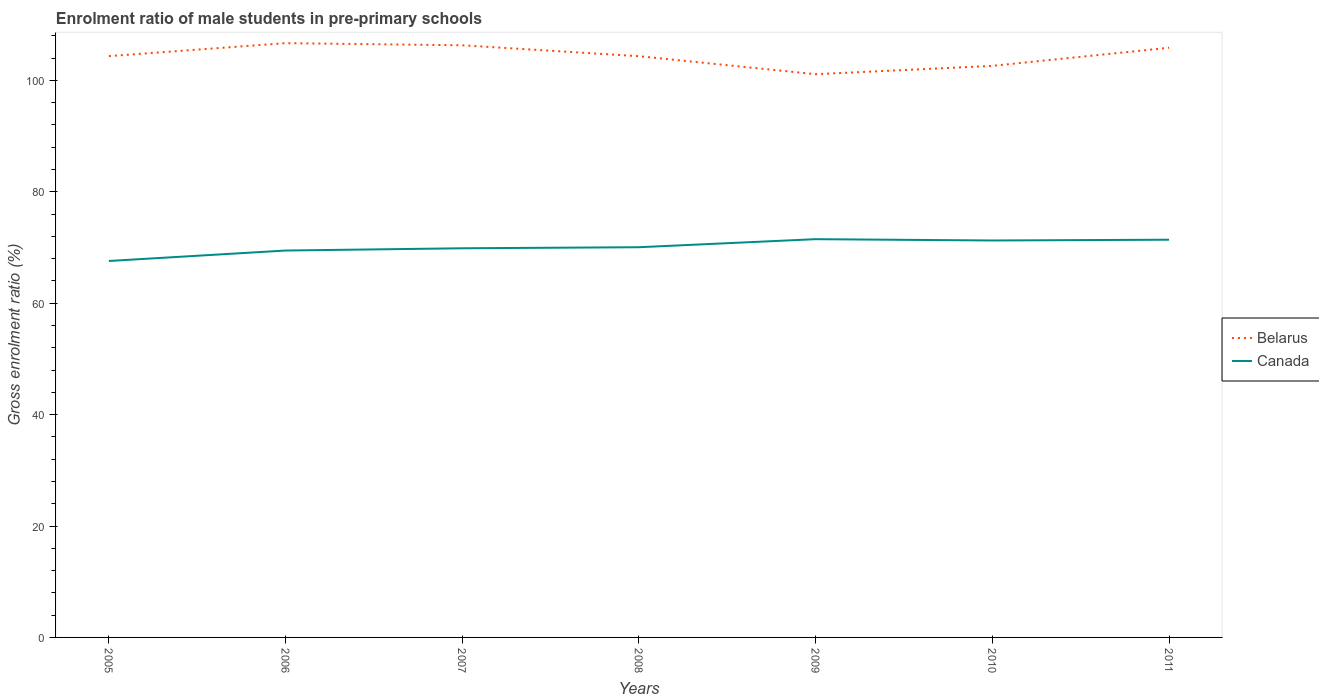How many different coloured lines are there?
Provide a short and direct response. 2. Is the number of lines equal to the number of legend labels?
Make the answer very short. Yes. Across all years, what is the maximum enrolment ratio of male students in pre-primary schools in Canada?
Keep it short and to the point. 67.57. In which year was the enrolment ratio of male students in pre-primary schools in Canada maximum?
Provide a short and direct response. 2005. What is the total enrolment ratio of male students in pre-primary schools in Canada in the graph?
Provide a short and direct response. -1.64. What is the difference between the highest and the second highest enrolment ratio of male students in pre-primary schools in Belarus?
Ensure brevity in your answer.  5.57. What is the difference between the highest and the lowest enrolment ratio of male students in pre-primary schools in Belarus?
Offer a terse response. 3. Is the enrolment ratio of male students in pre-primary schools in Belarus strictly greater than the enrolment ratio of male students in pre-primary schools in Canada over the years?
Your answer should be very brief. No. How many lines are there?
Keep it short and to the point. 2. How many years are there in the graph?
Offer a very short reply. 7. Does the graph contain any zero values?
Make the answer very short. No. Does the graph contain grids?
Your answer should be compact. No. Where does the legend appear in the graph?
Keep it short and to the point. Center right. How many legend labels are there?
Your answer should be very brief. 2. What is the title of the graph?
Make the answer very short. Enrolment ratio of male students in pre-primary schools. What is the label or title of the X-axis?
Offer a terse response. Years. What is the label or title of the Y-axis?
Ensure brevity in your answer.  Gross enrolment ratio (%). What is the Gross enrolment ratio (%) of Belarus in 2005?
Your response must be concise. 104.34. What is the Gross enrolment ratio (%) in Canada in 2005?
Your answer should be compact. 67.57. What is the Gross enrolment ratio (%) of Belarus in 2006?
Your answer should be very brief. 106.67. What is the Gross enrolment ratio (%) of Canada in 2006?
Your answer should be compact. 69.45. What is the Gross enrolment ratio (%) of Belarus in 2007?
Your answer should be compact. 106.29. What is the Gross enrolment ratio (%) of Canada in 2007?
Your answer should be very brief. 69.85. What is the Gross enrolment ratio (%) in Belarus in 2008?
Your answer should be compact. 104.33. What is the Gross enrolment ratio (%) of Canada in 2008?
Your answer should be very brief. 70.04. What is the Gross enrolment ratio (%) of Belarus in 2009?
Offer a very short reply. 101.1. What is the Gross enrolment ratio (%) in Canada in 2009?
Make the answer very short. 71.49. What is the Gross enrolment ratio (%) of Belarus in 2010?
Your response must be concise. 102.59. What is the Gross enrolment ratio (%) of Canada in 2010?
Keep it short and to the point. 71.25. What is the Gross enrolment ratio (%) in Belarus in 2011?
Your response must be concise. 105.85. What is the Gross enrolment ratio (%) of Canada in 2011?
Your response must be concise. 71.39. Across all years, what is the maximum Gross enrolment ratio (%) in Belarus?
Make the answer very short. 106.67. Across all years, what is the maximum Gross enrolment ratio (%) of Canada?
Make the answer very short. 71.49. Across all years, what is the minimum Gross enrolment ratio (%) of Belarus?
Keep it short and to the point. 101.1. Across all years, what is the minimum Gross enrolment ratio (%) in Canada?
Keep it short and to the point. 67.57. What is the total Gross enrolment ratio (%) of Belarus in the graph?
Provide a short and direct response. 731.17. What is the total Gross enrolment ratio (%) in Canada in the graph?
Offer a terse response. 491.04. What is the difference between the Gross enrolment ratio (%) of Belarus in 2005 and that in 2006?
Provide a short and direct response. -2.33. What is the difference between the Gross enrolment ratio (%) of Canada in 2005 and that in 2006?
Your answer should be compact. -1.88. What is the difference between the Gross enrolment ratio (%) in Belarus in 2005 and that in 2007?
Give a very brief answer. -1.95. What is the difference between the Gross enrolment ratio (%) in Canada in 2005 and that in 2007?
Ensure brevity in your answer.  -2.28. What is the difference between the Gross enrolment ratio (%) of Belarus in 2005 and that in 2008?
Your response must be concise. 0.01. What is the difference between the Gross enrolment ratio (%) in Canada in 2005 and that in 2008?
Your answer should be compact. -2.47. What is the difference between the Gross enrolment ratio (%) in Belarus in 2005 and that in 2009?
Offer a very short reply. 3.24. What is the difference between the Gross enrolment ratio (%) of Canada in 2005 and that in 2009?
Provide a short and direct response. -3.91. What is the difference between the Gross enrolment ratio (%) of Belarus in 2005 and that in 2010?
Offer a terse response. 1.75. What is the difference between the Gross enrolment ratio (%) of Canada in 2005 and that in 2010?
Your answer should be compact. -3.68. What is the difference between the Gross enrolment ratio (%) in Belarus in 2005 and that in 2011?
Your response must be concise. -1.5. What is the difference between the Gross enrolment ratio (%) of Canada in 2005 and that in 2011?
Provide a succinct answer. -3.82. What is the difference between the Gross enrolment ratio (%) in Belarus in 2006 and that in 2007?
Provide a succinct answer. 0.38. What is the difference between the Gross enrolment ratio (%) in Canada in 2006 and that in 2007?
Ensure brevity in your answer.  -0.4. What is the difference between the Gross enrolment ratio (%) in Belarus in 2006 and that in 2008?
Your answer should be compact. 2.35. What is the difference between the Gross enrolment ratio (%) of Canada in 2006 and that in 2008?
Your response must be concise. -0.59. What is the difference between the Gross enrolment ratio (%) in Belarus in 2006 and that in 2009?
Give a very brief answer. 5.57. What is the difference between the Gross enrolment ratio (%) of Canada in 2006 and that in 2009?
Make the answer very short. -2.04. What is the difference between the Gross enrolment ratio (%) of Belarus in 2006 and that in 2010?
Offer a very short reply. 4.08. What is the difference between the Gross enrolment ratio (%) in Canada in 2006 and that in 2010?
Provide a succinct answer. -1.8. What is the difference between the Gross enrolment ratio (%) in Belarus in 2006 and that in 2011?
Your answer should be very brief. 0.83. What is the difference between the Gross enrolment ratio (%) of Canada in 2006 and that in 2011?
Make the answer very short. -1.94. What is the difference between the Gross enrolment ratio (%) of Belarus in 2007 and that in 2008?
Provide a succinct answer. 1.96. What is the difference between the Gross enrolment ratio (%) of Canada in 2007 and that in 2008?
Offer a very short reply. -0.19. What is the difference between the Gross enrolment ratio (%) of Belarus in 2007 and that in 2009?
Make the answer very short. 5.19. What is the difference between the Gross enrolment ratio (%) in Canada in 2007 and that in 2009?
Offer a very short reply. -1.64. What is the difference between the Gross enrolment ratio (%) in Belarus in 2007 and that in 2010?
Offer a terse response. 3.7. What is the difference between the Gross enrolment ratio (%) of Canada in 2007 and that in 2010?
Your answer should be very brief. -1.4. What is the difference between the Gross enrolment ratio (%) in Belarus in 2007 and that in 2011?
Ensure brevity in your answer.  0.44. What is the difference between the Gross enrolment ratio (%) of Canada in 2007 and that in 2011?
Your answer should be very brief. -1.54. What is the difference between the Gross enrolment ratio (%) in Belarus in 2008 and that in 2009?
Offer a terse response. 3.23. What is the difference between the Gross enrolment ratio (%) of Canada in 2008 and that in 2009?
Your answer should be very brief. -1.45. What is the difference between the Gross enrolment ratio (%) in Belarus in 2008 and that in 2010?
Make the answer very short. 1.73. What is the difference between the Gross enrolment ratio (%) of Canada in 2008 and that in 2010?
Provide a succinct answer. -1.21. What is the difference between the Gross enrolment ratio (%) of Belarus in 2008 and that in 2011?
Provide a short and direct response. -1.52. What is the difference between the Gross enrolment ratio (%) in Canada in 2008 and that in 2011?
Offer a very short reply. -1.35. What is the difference between the Gross enrolment ratio (%) of Belarus in 2009 and that in 2010?
Keep it short and to the point. -1.49. What is the difference between the Gross enrolment ratio (%) in Canada in 2009 and that in 2010?
Offer a terse response. 0.24. What is the difference between the Gross enrolment ratio (%) of Belarus in 2009 and that in 2011?
Make the answer very short. -4.75. What is the difference between the Gross enrolment ratio (%) of Canada in 2009 and that in 2011?
Ensure brevity in your answer.  0.1. What is the difference between the Gross enrolment ratio (%) in Belarus in 2010 and that in 2011?
Keep it short and to the point. -3.25. What is the difference between the Gross enrolment ratio (%) in Canada in 2010 and that in 2011?
Provide a short and direct response. -0.14. What is the difference between the Gross enrolment ratio (%) of Belarus in 2005 and the Gross enrolment ratio (%) of Canada in 2006?
Your response must be concise. 34.89. What is the difference between the Gross enrolment ratio (%) in Belarus in 2005 and the Gross enrolment ratio (%) in Canada in 2007?
Provide a succinct answer. 34.49. What is the difference between the Gross enrolment ratio (%) in Belarus in 2005 and the Gross enrolment ratio (%) in Canada in 2008?
Provide a short and direct response. 34.3. What is the difference between the Gross enrolment ratio (%) in Belarus in 2005 and the Gross enrolment ratio (%) in Canada in 2009?
Give a very brief answer. 32.85. What is the difference between the Gross enrolment ratio (%) of Belarus in 2005 and the Gross enrolment ratio (%) of Canada in 2010?
Offer a terse response. 33.09. What is the difference between the Gross enrolment ratio (%) of Belarus in 2005 and the Gross enrolment ratio (%) of Canada in 2011?
Give a very brief answer. 32.95. What is the difference between the Gross enrolment ratio (%) in Belarus in 2006 and the Gross enrolment ratio (%) in Canada in 2007?
Offer a very short reply. 36.82. What is the difference between the Gross enrolment ratio (%) in Belarus in 2006 and the Gross enrolment ratio (%) in Canada in 2008?
Your answer should be compact. 36.63. What is the difference between the Gross enrolment ratio (%) in Belarus in 2006 and the Gross enrolment ratio (%) in Canada in 2009?
Ensure brevity in your answer.  35.19. What is the difference between the Gross enrolment ratio (%) of Belarus in 2006 and the Gross enrolment ratio (%) of Canada in 2010?
Offer a very short reply. 35.42. What is the difference between the Gross enrolment ratio (%) in Belarus in 2006 and the Gross enrolment ratio (%) in Canada in 2011?
Offer a terse response. 35.28. What is the difference between the Gross enrolment ratio (%) of Belarus in 2007 and the Gross enrolment ratio (%) of Canada in 2008?
Your answer should be very brief. 36.25. What is the difference between the Gross enrolment ratio (%) of Belarus in 2007 and the Gross enrolment ratio (%) of Canada in 2009?
Give a very brief answer. 34.8. What is the difference between the Gross enrolment ratio (%) of Belarus in 2007 and the Gross enrolment ratio (%) of Canada in 2010?
Give a very brief answer. 35.04. What is the difference between the Gross enrolment ratio (%) of Belarus in 2007 and the Gross enrolment ratio (%) of Canada in 2011?
Make the answer very short. 34.9. What is the difference between the Gross enrolment ratio (%) of Belarus in 2008 and the Gross enrolment ratio (%) of Canada in 2009?
Give a very brief answer. 32.84. What is the difference between the Gross enrolment ratio (%) in Belarus in 2008 and the Gross enrolment ratio (%) in Canada in 2010?
Offer a terse response. 33.08. What is the difference between the Gross enrolment ratio (%) of Belarus in 2008 and the Gross enrolment ratio (%) of Canada in 2011?
Provide a short and direct response. 32.94. What is the difference between the Gross enrolment ratio (%) in Belarus in 2009 and the Gross enrolment ratio (%) in Canada in 2010?
Offer a terse response. 29.85. What is the difference between the Gross enrolment ratio (%) in Belarus in 2009 and the Gross enrolment ratio (%) in Canada in 2011?
Offer a very short reply. 29.71. What is the difference between the Gross enrolment ratio (%) in Belarus in 2010 and the Gross enrolment ratio (%) in Canada in 2011?
Keep it short and to the point. 31.2. What is the average Gross enrolment ratio (%) in Belarus per year?
Provide a succinct answer. 104.45. What is the average Gross enrolment ratio (%) in Canada per year?
Give a very brief answer. 70.15. In the year 2005, what is the difference between the Gross enrolment ratio (%) in Belarus and Gross enrolment ratio (%) in Canada?
Keep it short and to the point. 36.77. In the year 2006, what is the difference between the Gross enrolment ratio (%) of Belarus and Gross enrolment ratio (%) of Canada?
Your answer should be compact. 37.23. In the year 2007, what is the difference between the Gross enrolment ratio (%) of Belarus and Gross enrolment ratio (%) of Canada?
Your answer should be very brief. 36.44. In the year 2008, what is the difference between the Gross enrolment ratio (%) of Belarus and Gross enrolment ratio (%) of Canada?
Make the answer very short. 34.29. In the year 2009, what is the difference between the Gross enrolment ratio (%) in Belarus and Gross enrolment ratio (%) in Canada?
Make the answer very short. 29.61. In the year 2010, what is the difference between the Gross enrolment ratio (%) in Belarus and Gross enrolment ratio (%) in Canada?
Keep it short and to the point. 31.34. In the year 2011, what is the difference between the Gross enrolment ratio (%) of Belarus and Gross enrolment ratio (%) of Canada?
Provide a short and direct response. 34.46. What is the ratio of the Gross enrolment ratio (%) of Belarus in 2005 to that in 2006?
Ensure brevity in your answer.  0.98. What is the ratio of the Gross enrolment ratio (%) in Canada in 2005 to that in 2006?
Provide a short and direct response. 0.97. What is the ratio of the Gross enrolment ratio (%) of Belarus in 2005 to that in 2007?
Your response must be concise. 0.98. What is the ratio of the Gross enrolment ratio (%) in Canada in 2005 to that in 2007?
Your answer should be compact. 0.97. What is the ratio of the Gross enrolment ratio (%) of Belarus in 2005 to that in 2008?
Offer a terse response. 1. What is the ratio of the Gross enrolment ratio (%) in Canada in 2005 to that in 2008?
Your answer should be compact. 0.96. What is the ratio of the Gross enrolment ratio (%) in Belarus in 2005 to that in 2009?
Provide a succinct answer. 1.03. What is the ratio of the Gross enrolment ratio (%) of Canada in 2005 to that in 2009?
Make the answer very short. 0.95. What is the ratio of the Gross enrolment ratio (%) of Canada in 2005 to that in 2010?
Provide a succinct answer. 0.95. What is the ratio of the Gross enrolment ratio (%) in Belarus in 2005 to that in 2011?
Give a very brief answer. 0.99. What is the ratio of the Gross enrolment ratio (%) of Canada in 2005 to that in 2011?
Provide a succinct answer. 0.95. What is the ratio of the Gross enrolment ratio (%) of Canada in 2006 to that in 2007?
Keep it short and to the point. 0.99. What is the ratio of the Gross enrolment ratio (%) in Belarus in 2006 to that in 2008?
Make the answer very short. 1.02. What is the ratio of the Gross enrolment ratio (%) of Canada in 2006 to that in 2008?
Provide a short and direct response. 0.99. What is the ratio of the Gross enrolment ratio (%) in Belarus in 2006 to that in 2009?
Offer a terse response. 1.06. What is the ratio of the Gross enrolment ratio (%) of Canada in 2006 to that in 2009?
Give a very brief answer. 0.97. What is the ratio of the Gross enrolment ratio (%) in Belarus in 2006 to that in 2010?
Keep it short and to the point. 1.04. What is the ratio of the Gross enrolment ratio (%) of Canada in 2006 to that in 2010?
Provide a short and direct response. 0.97. What is the ratio of the Gross enrolment ratio (%) in Canada in 2006 to that in 2011?
Keep it short and to the point. 0.97. What is the ratio of the Gross enrolment ratio (%) in Belarus in 2007 to that in 2008?
Keep it short and to the point. 1.02. What is the ratio of the Gross enrolment ratio (%) of Canada in 2007 to that in 2008?
Make the answer very short. 1. What is the ratio of the Gross enrolment ratio (%) in Belarus in 2007 to that in 2009?
Keep it short and to the point. 1.05. What is the ratio of the Gross enrolment ratio (%) of Canada in 2007 to that in 2009?
Ensure brevity in your answer.  0.98. What is the ratio of the Gross enrolment ratio (%) in Belarus in 2007 to that in 2010?
Provide a succinct answer. 1.04. What is the ratio of the Gross enrolment ratio (%) in Canada in 2007 to that in 2010?
Your answer should be very brief. 0.98. What is the ratio of the Gross enrolment ratio (%) of Canada in 2007 to that in 2011?
Your response must be concise. 0.98. What is the ratio of the Gross enrolment ratio (%) in Belarus in 2008 to that in 2009?
Keep it short and to the point. 1.03. What is the ratio of the Gross enrolment ratio (%) in Canada in 2008 to that in 2009?
Provide a short and direct response. 0.98. What is the ratio of the Gross enrolment ratio (%) in Belarus in 2008 to that in 2010?
Keep it short and to the point. 1.02. What is the ratio of the Gross enrolment ratio (%) in Canada in 2008 to that in 2010?
Keep it short and to the point. 0.98. What is the ratio of the Gross enrolment ratio (%) in Belarus in 2008 to that in 2011?
Make the answer very short. 0.99. What is the ratio of the Gross enrolment ratio (%) of Canada in 2008 to that in 2011?
Your answer should be very brief. 0.98. What is the ratio of the Gross enrolment ratio (%) in Belarus in 2009 to that in 2010?
Keep it short and to the point. 0.99. What is the ratio of the Gross enrolment ratio (%) in Canada in 2009 to that in 2010?
Your answer should be compact. 1. What is the ratio of the Gross enrolment ratio (%) in Belarus in 2009 to that in 2011?
Ensure brevity in your answer.  0.96. What is the ratio of the Gross enrolment ratio (%) of Canada in 2009 to that in 2011?
Provide a short and direct response. 1. What is the ratio of the Gross enrolment ratio (%) of Belarus in 2010 to that in 2011?
Provide a succinct answer. 0.97. What is the difference between the highest and the second highest Gross enrolment ratio (%) of Belarus?
Give a very brief answer. 0.38. What is the difference between the highest and the second highest Gross enrolment ratio (%) of Canada?
Provide a short and direct response. 0.1. What is the difference between the highest and the lowest Gross enrolment ratio (%) of Belarus?
Your response must be concise. 5.57. What is the difference between the highest and the lowest Gross enrolment ratio (%) in Canada?
Your response must be concise. 3.91. 